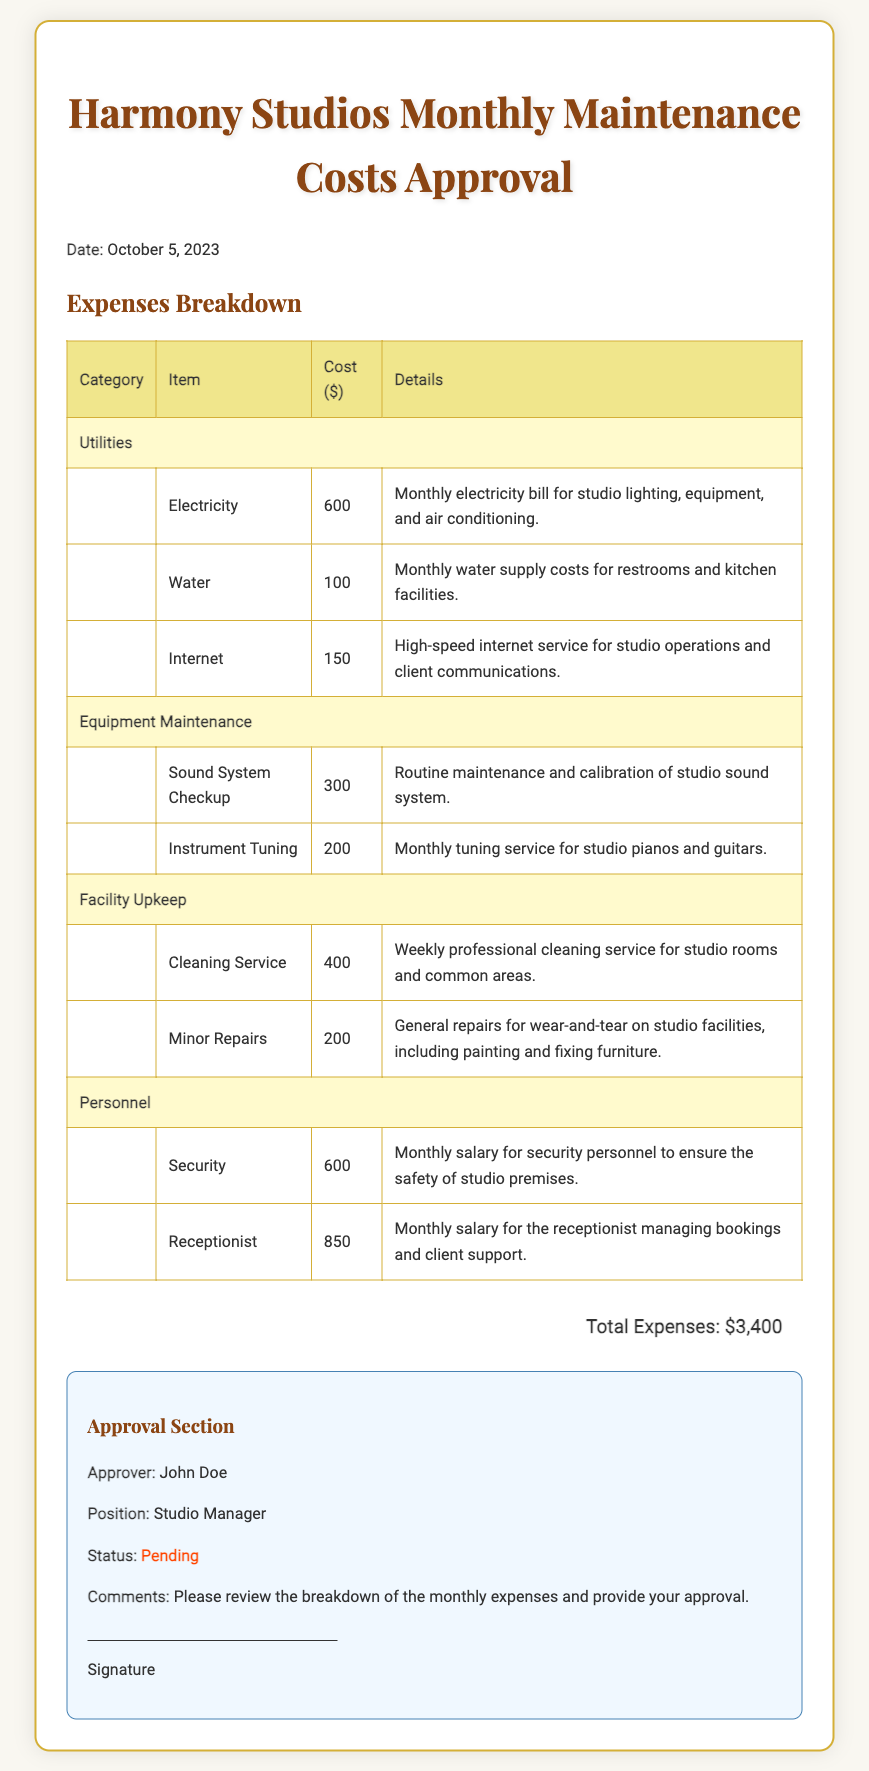What is the date of the document? The date is explicitly mentioned in the document under the title.
Answer: October 5, 2023 What is the total monthly maintenance cost? The total monthly maintenance cost is presented at the end of the expense breakdown.
Answer: $3,400 Who is the approver of the ballot? The name of the approver is stated in the approval section of the document.
Answer: John Doe What category does the cleaning service fall under? The category of the cleaning service is specified in the table of expenses.
Answer: Facility Upkeep How much does the security personnel cost? The cost for security personnel is detailed under the personnel category in the expenses table.
Answer: $600 What item costs $200 in the document? The item costing $200 is mentioned under the equipment maintenance category in the expense breakdown.
Answer: Instrument Tuning What is the status of the approval? The status of the approval is mentioned in the approval section of the document.
Answer: Pending Which service has the highest cost? The highest cost service is indicated in the expenses table, revealing comparison among categories.
Answer: Receptionist What is the monthly cost of water? The monthly cost of water can be found under the utilities category in the expense breakdown.
Answer: $100 